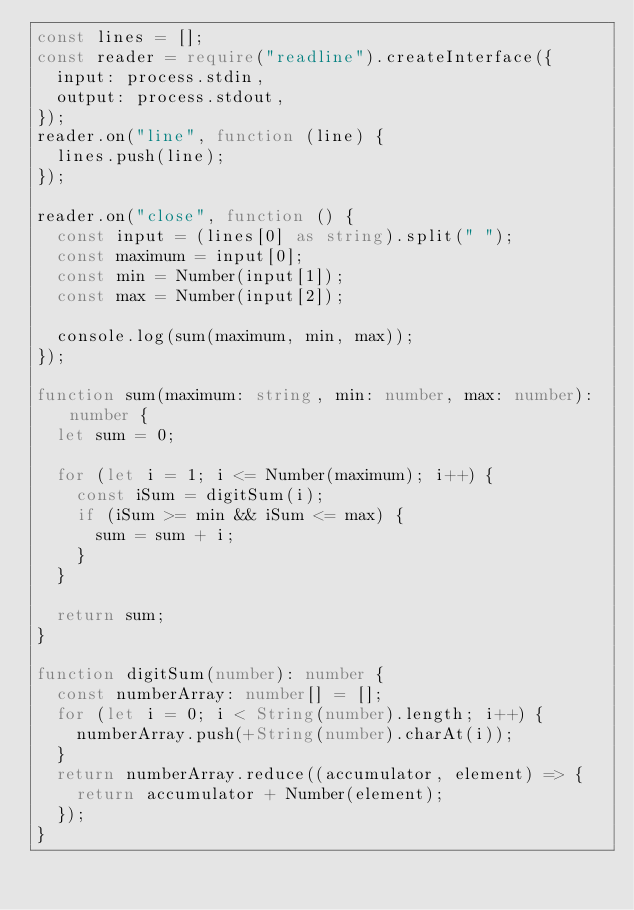<code> <loc_0><loc_0><loc_500><loc_500><_TypeScript_>const lines = [];
const reader = require("readline").createInterface({
  input: process.stdin,
  output: process.stdout,
});
reader.on("line", function (line) {
  lines.push(line);
});

reader.on("close", function () {
  const input = (lines[0] as string).split(" ");
  const maximum = input[0];
  const min = Number(input[1]);
  const max = Number(input[2]);

  console.log(sum(maximum, min, max));
});

function sum(maximum: string, min: number, max: number): number {
  let sum = 0;

  for (let i = 1; i <= Number(maximum); i++) {
    const iSum = digitSum(i);
    if (iSum >= min && iSum <= max) {
      sum = sum + i;
    }
  }

  return sum;
}

function digitSum(number): number {
  const numberArray: number[] = [];
  for (let i = 0; i < String(number).length; i++) {
    numberArray.push(+String(number).charAt(i));
  }
  return numberArray.reduce((accumulator, element) => {
    return accumulator + Number(element);
  });
}</code> 